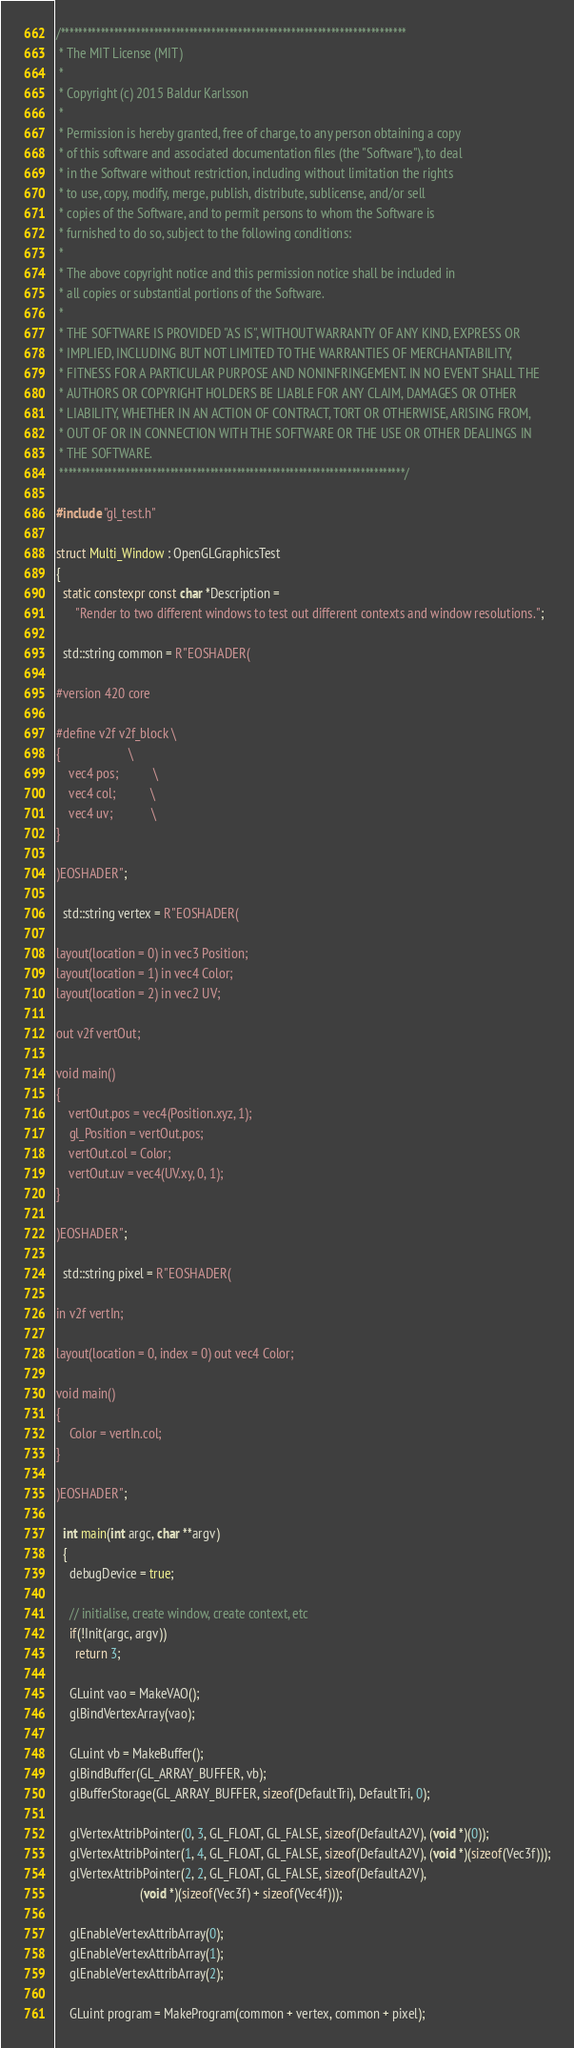Convert code to text. <code><loc_0><loc_0><loc_500><loc_500><_C++_>/******************************************************************************
 * The MIT License (MIT)
 *
 * Copyright (c) 2015 Baldur Karlsson
 *
 * Permission is hereby granted, free of charge, to any person obtaining a copy
 * of this software and associated documentation files (the "Software"), to deal
 * in the Software without restriction, including without limitation the rights
 * to use, copy, modify, merge, publish, distribute, sublicense, and/or sell
 * copies of the Software, and to permit persons to whom the Software is
 * furnished to do so, subject to the following conditions:
 *
 * The above copyright notice and this permission notice shall be included in
 * all copies or substantial portions of the Software.
 *
 * THE SOFTWARE IS PROVIDED "AS IS", WITHOUT WARRANTY OF ANY KIND, EXPRESS OR
 * IMPLIED, INCLUDING BUT NOT LIMITED TO THE WARRANTIES OF MERCHANTABILITY,
 * FITNESS FOR A PARTICULAR PURPOSE AND NONINFRINGEMENT. IN NO EVENT SHALL THE
 * AUTHORS OR COPYRIGHT HOLDERS BE LIABLE FOR ANY CLAIM, DAMAGES OR OTHER
 * LIABILITY, WHETHER IN AN ACTION OF CONTRACT, TORT OR OTHERWISE, ARISING FROM,
 * OUT OF OR IN CONNECTION WITH THE SOFTWARE OR THE USE OR OTHER DEALINGS IN
 * THE SOFTWARE.
 ******************************************************************************/

#include "gl_test.h"

struct Multi_Window : OpenGLGraphicsTest
{
  static constexpr const char *Description =
      "Render to two different windows to test out different contexts and window resolutions.";

  std::string common = R"EOSHADER(

#version 420 core

#define v2f v2f_block \
{                     \
	vec4 pos;           \
	vec4 col;           \
	vec4 uv;            \
}

)EOSHADER";

  std::string vertex = R"EOSHADER(

layout(location = 0) in vec3 Position;
layout(location = 1) in vec4 Color;
layout(location = 2) in vec2 UV;

out v2f vertOut;

void main()
{
	vertOut.pos = vec4(Position.xyz, 1);
	gl_Position = vertOut.pos;
	vertOut.col = Color;
	vertOut.uv = vec4(UV.xy, 0, 1);
}

)EOSHADER";

  std::string pixel = R"EOSHADER(

in v2f vertIn;

layout(location = 0, index = 0) out vec4 Color;

void main()
{
	Color = vertIn.col;
}

)EOSHADER";

  int main(int argc, char **argv)
  {
    debugDevice = true;

    // initialise, create window, create context, etc
    if(!Init(argc, argv))
      return 3;

    GLuint vao = MakeVAO();
    glBindVertexArray(vao);

    GLuint vb = MakeBuffer();
    glBindBuffer(GL_ARRAY_BUFFER, vb);
    glBufferStorage(GL_ARRAY_BUFFER, sizeof(DefaultTri), DefaultTri, 0);

    glVertexAttribPointer(0, 3, GL_FLOAT, GL_FALSE, sizeof(DefaultA2V), (void *)(0));
    glVertexAttribPointer(1, 4, GL_FLOAT, GL_FALSE, sizeof(DefaultA2V), (void *)(sizeof(Vec3f)));
    glVertexAttribPointer(2, 2, GL_FLOAT, GL_FALSE, sizeof(DefaultA2V),
                          (void *)(sizeof(Vec3f) + sizeof(Vec4f)));

    glEnableVertexAttribArray(0);
    glEnableVertexAttribArray(1);
    glEnableVertexAttribArray(2);

    GLuint program = MakeProgram(common + vertex, common + pixel);</code> 